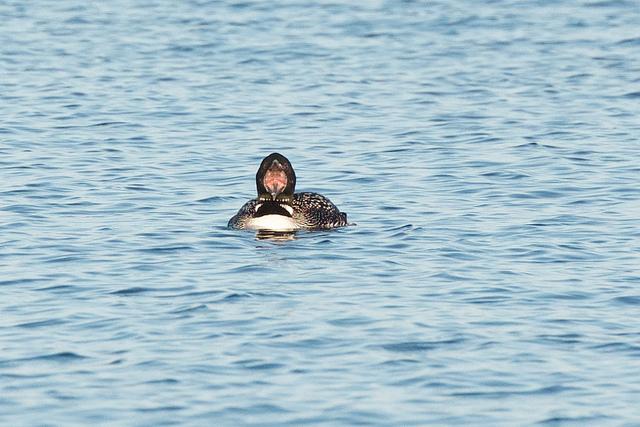How many ducks are in the photo?
Give a very brief answer. 1. Are the ducks walking?
Concise answer only. No. Is this a man?
Write a very short answer. No. Is this on land?
Concise answer only. No. Is this duck on land?
Be succinct. No. 